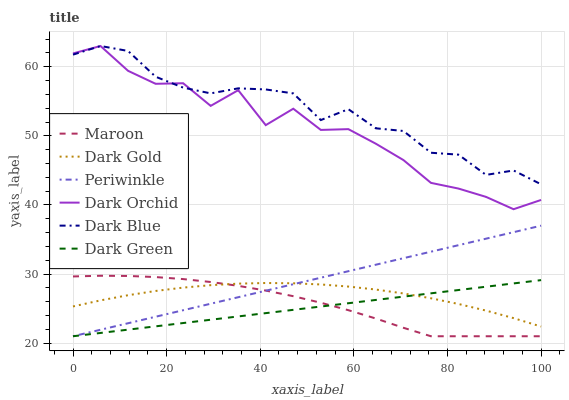Does Dark Green have the minimum area under the curve?
Answer yes or no. Yes. Does Dark Blue have the maximum area under the curve?
Answer yes or no. Yes. Does Dark Orchid have the minimum area under the curve?
Answer yes or no. No. Does Dark Orchid have the maximum area under the curve?
Answer yes or no. No. Is Periwinkle the smoothest?
Answer yes or no. Yes. Is Dark Orchid the roughest?
Answer yes or no. Yes. Is Dark Blue the smoothest?
Answer yes or no. No. Is Dark Blue the roughest?
Answer yes or no. No. Does Periwinkle have the lowest value?
Answer yes or no. Yes. Does Dark Orchid have the lowest value?
Answer yes or no. No. Does Dark Blue have the highest value?
Answer yes or no. Yes. Does Periwinkle have the highest value?
Answer yes or no. No. Is Periwinkle less than Dark Orchid?
Answer yes or no. Yes. Is Dark Blue greater than Periwinkle?
Answer yes or no. Yes. Does Periwinkle intersect Dark Green?
Answer yes or no. Yes. Is Periwinkle less than Dark Green?
Answer yes or no. No. Is Periwinkle greater than Dark Green?
Answer yes or no. No. Does Periwinkle intersect Dark Orchid?
Answer yes or no. No. 